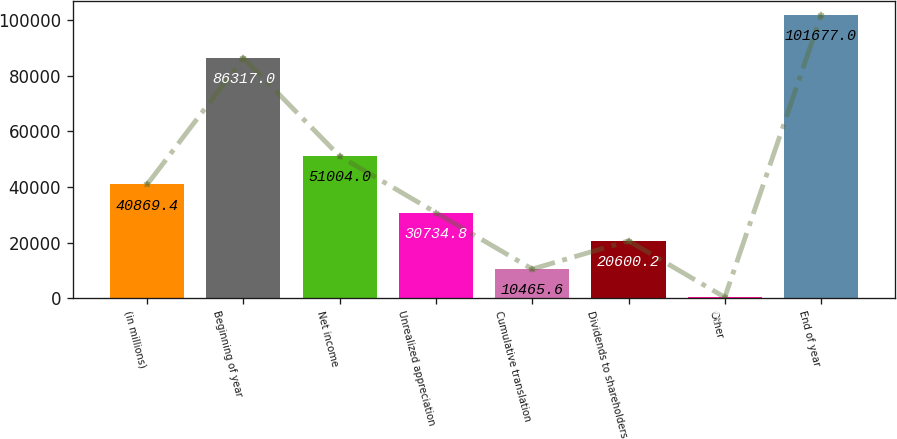<chart> <loc_0><loc_0><loc_500><loc_500><bar_chart><fcel>(in millions)<fcel>Beginning of year<fcel>Net income<fcel>Unrealized appreciation<fcel>Cumulative translation<fcel>Dividends to shareholders<fcel>Other<fcel>End of year<nl><fcel>40869.4<fcel>86317<fcel>51004<fcel>30734.8<fcel>10465.6<fcel>20600.2<fcel>331<fcel>101677<nl></chart> 